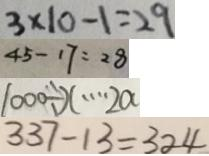Convert formula to latex. <formula><loc_0><loc_0><loc_500><loc_500>3 \times 1 0 - 1 = 2 9 
 4 5 - 1 7 = 2 8 
 1 0 0 0 \div x \cdots 2 a 
 3 3 7 - 1 3 = 3 2 4</formula> 